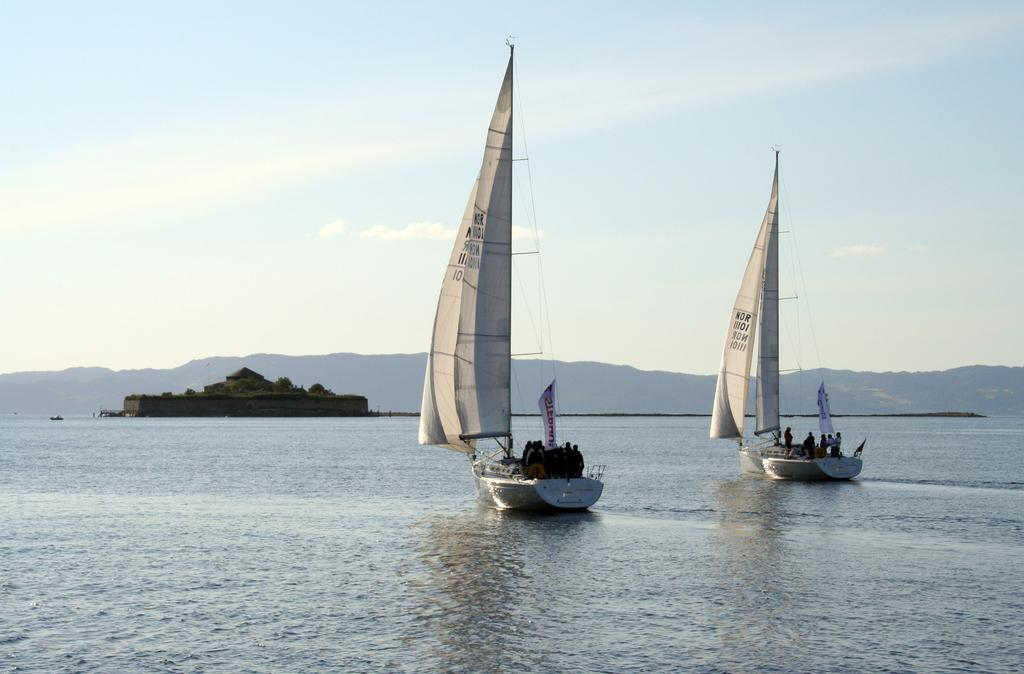What can be seen in the image related to water transportation? There are two boats in the image. Where are the boats located? The boats are on the water. What are the people in the boats doing? There are people standing in the boats. What can be seen in the background of the image? There are mountains in the background of the image. How would you describe the sky in the image? The sky is visible in the image, with blue and white colors. What type of punishment is being handed out to the people in the boats in the image? There is no indication of punishment in the image; it simply shows two boats on the water with people standing in them. What kind of vessel is being used by the police in the image? There is no police presence or vessel mentioned in the image; it only features two boats on the water. 